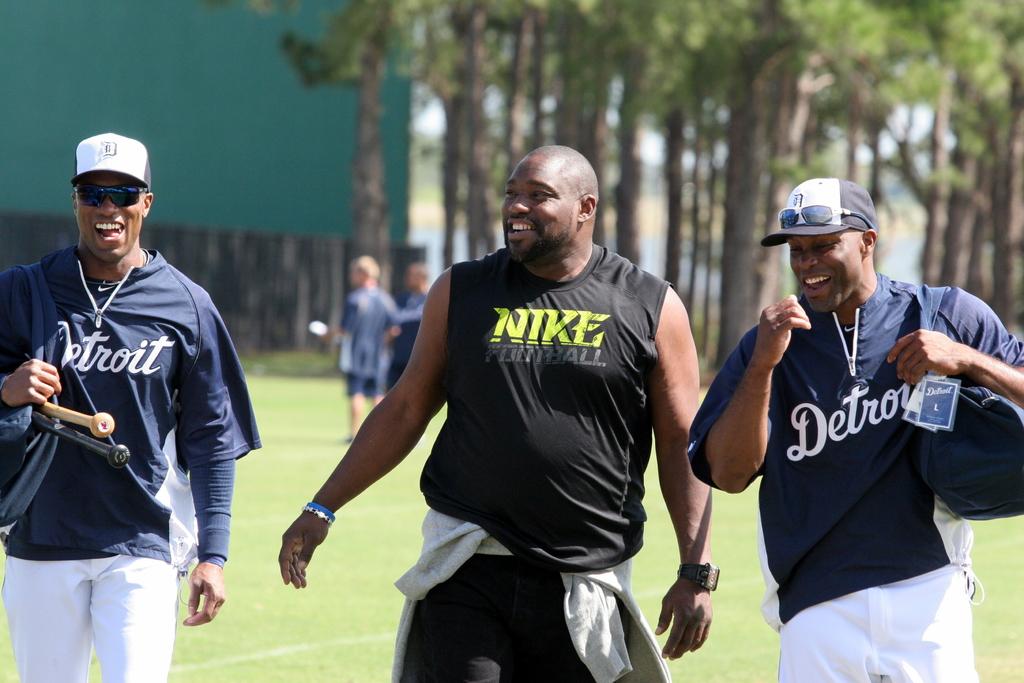Is this man sponsored by nike?
Give a very brief answer. Yes. What is the city name on the left shirt?
Your answer should be very brief. Detroit. 